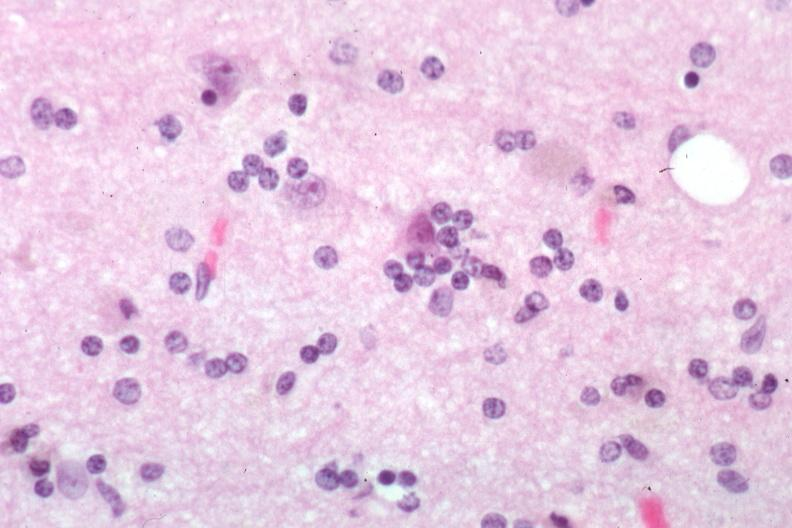s bone, skull present?
Answer the question using a single word or phrase. No 